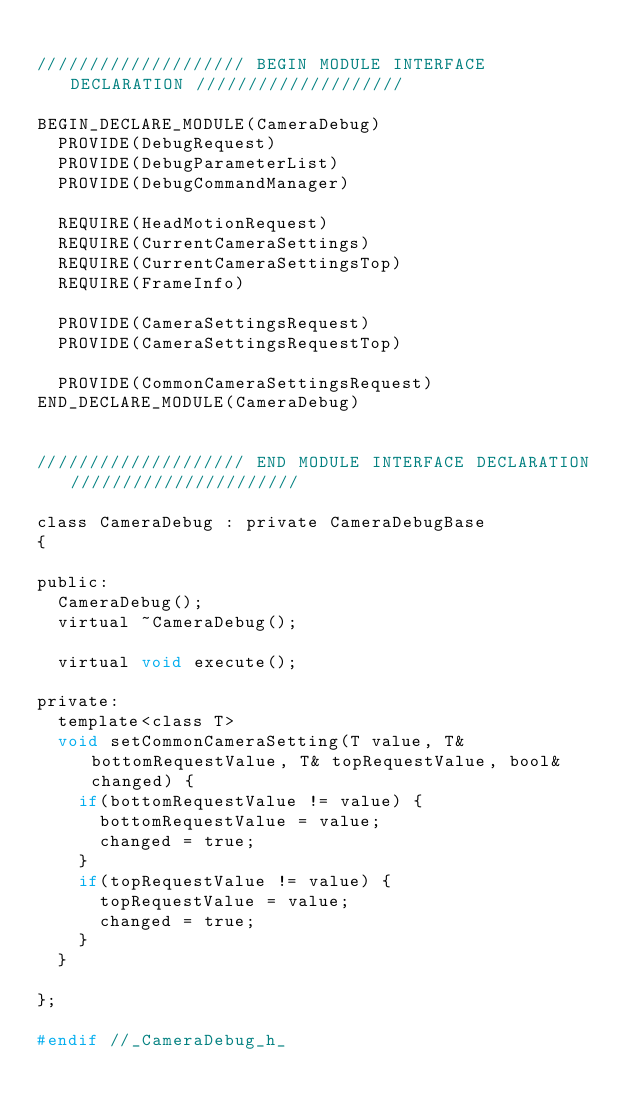<code> <loc_0><loc_0><loc_500><loc_500><_C_>
//////////////////// BEGIN MODULE INTERFACE DECLARATION ////////////////////

BEGIN_DECLARE_MODULE(CameraDebug)
  PROVIDE(DebugRequest)
  PROVIDE(DebugParameterList)
  PROVIDE(DebugCommandManager)

  REQUIRE(HeadMotionRequest)
  REQUIRE(CurrentCameraSettings)
  REQUIRE(CurrentCameraSettingsTop)
  REQUIRE(FrameInfo)

  PROVIDE(CameraSettingsRequest)
  PROVIDE(CameraSettingsRequestTop)

  PROVIDE(CommonCameraSettingsRequest)
END_DECLARE_MODULE(CameraDebug)


//////////////////// END MODULE INTERFACE DECLARATION //////////////////////

class CameraDebug : private CameraDebugBase
{

public:
  CameraDebug();
  virtual ~CameraDebug();

  virtual void execute();

private:
  template<class T>
  void setCommonCameraSetting(T value, T& bottomRequestValue, T& topRequestValue, bool& changed) {
    if(bottomRequestValue != value) {
      bottomRequestValue = value;
      changed = true;
    }
    if(topRequestValue != value) {
      topRequestValue = value;
      changed = true;
    }
  }

};

#endif //_CameraDebug_h_


</code> 